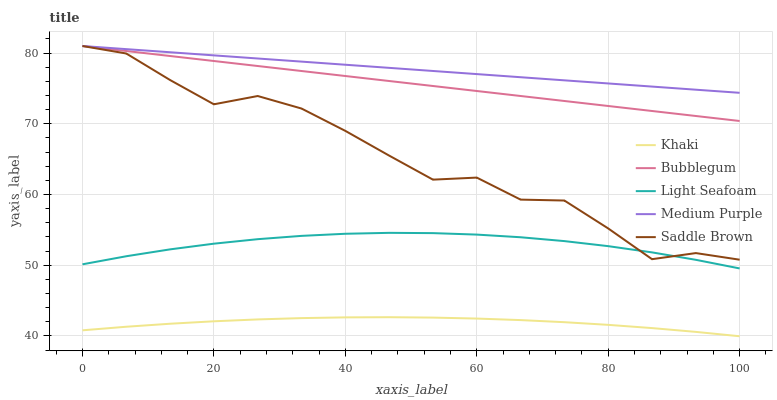Does Khaki have the minimum area under the curve?
Answer yes or no. Yes. Does Medium Purple have the maximum area under the curve?
Answer yes or no. Yes. Does Medium Purple have the minimum area under the curve?
Answer yes or no. No. Does Khaki have the maximum area under the curve?
Answer yes or no. No. Is Bubblegum the smoothest?
Answer yes or no. Yes. Is Saddle Brown the roughest?
Answer yes or no. Yes. Is Medium Purple the smoothest?
Answer yes or no. No. Is Medium Purple the roughest?
Answer yes or no. No. Does Khaki have the lowest value?
Answer yes or no. Yes. Does Medium Purple have the lowest value?
Answer yes or no. No. Does Bubblegum have the highest value?
Answer yes or no. Yes. Does Khaki have the highest value?
Answer yes or no. No. Is Khaki less than Saddle Brown?
Answer yes or no. Yes. Is Bubblegum greater than Khaki?
Answer yes or no. Yes. Does Saddle Brown intersect Bubblegum?
Answer yes or no. Yes. Is Saddle Brown less than Bubblegum?
Answer yes or no. No. Is Saddle Brown greater than Bubblegum?
Answer yes or no. No. Does Khaki intersect Saddle Brown?
Answer yes or no. No. 